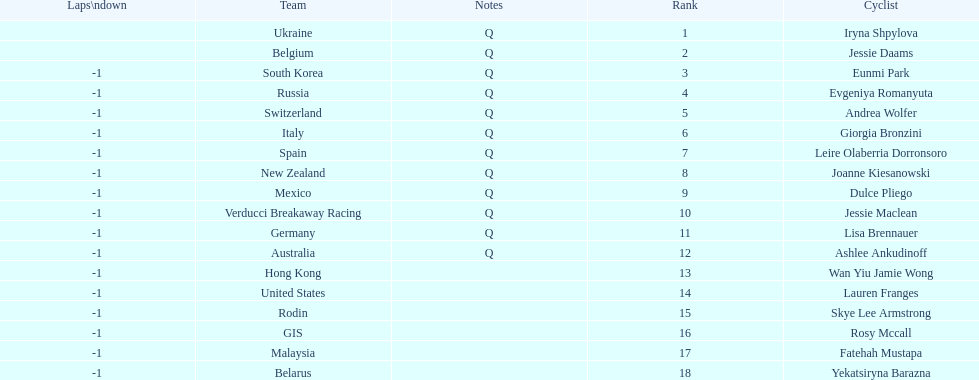How many consecutive notes are there? 12. 